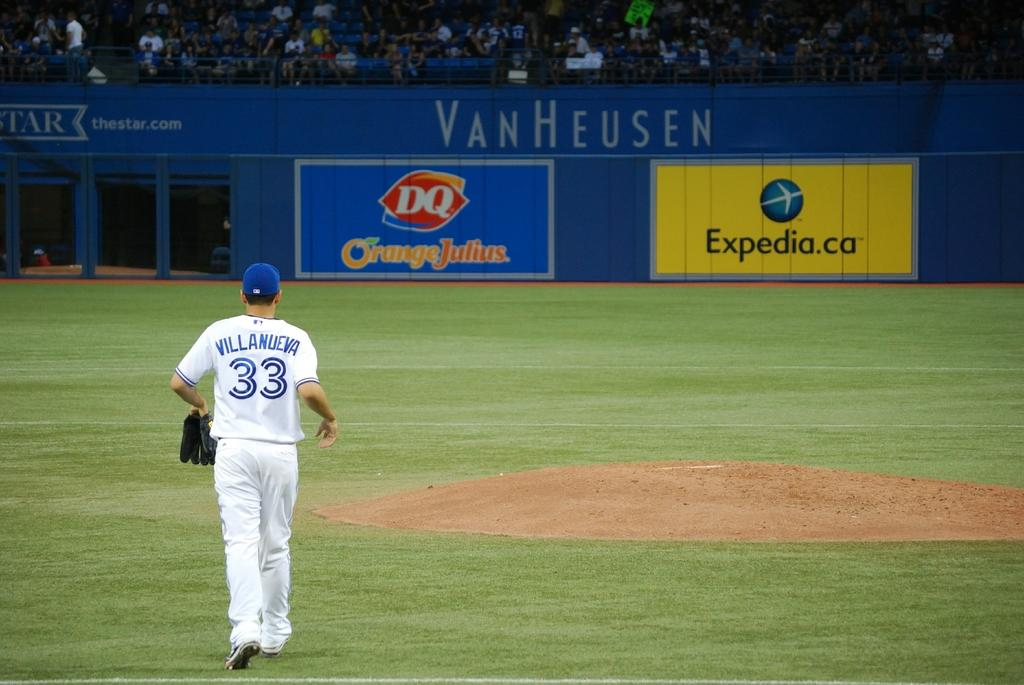<image>
Summarize the visual content of the image. a player with the number 33 on their jersey 